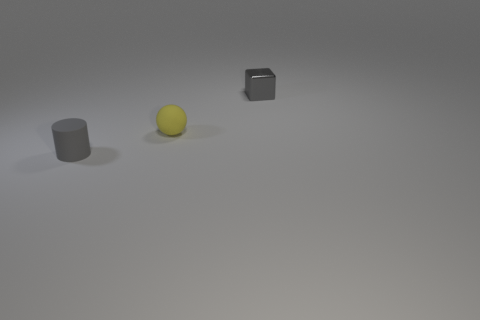Add 1 small cyan matte cubes. How many objects exist? 4 Add 2 big yellow cylinders. How many big yellow cylinders exist? 2 Subtract 0 cyan blocks. How many objects are left? 3 Subtract all cylinders. How many objects are left? 2 Subtract 1 cylinders. How many cylinders are left? 0 Subtract all blue balls. Subtract all green cylinders. How many balls are left? 1 Subtract all blue cylinders. How many cyan spheres are left? 0 Subtract all tiny gray objects. Subtract all small purple metallic cylinders. How many objects are left? 1 Add 3 tiny rubber balls. How many tiny rubber balls are left? 4 